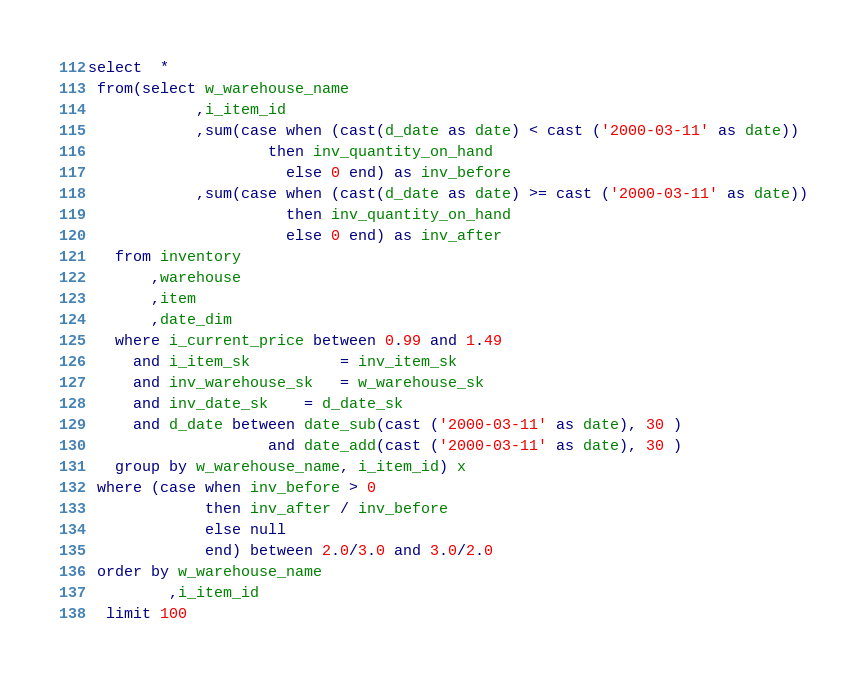<code> <loc_0><loc_0><loc_500><loc_500><_SQL_>select  *
 from(select w_warehouse_name
            ,i_item_id
            ,sum(case when (cast(d_date as date) < cast ('2000-03-11' as date))
	                then inv_quantity_on_hand 
                      else 0 end) as inv_before
            ,sum(case when (cast(d_date as date) >= cast ('2000-03-11' as date))
                      then inv_quantity_on_hand 
                      else 0 end) as inv_after
   from inventory
       ,warehouse
       ,item
       ,date_dim
   where i_current_price between 0.99 and 1.49
     and i_item_sk          = inv_item_sk
     and inv_warehouse_sk   = w_warehouse_sk
     and inv_date_sk    = d_date_sk
     and d_date between date_sub(cast ('2000-03-11' as date), 30 )
                    and date_add(cast ('2000-03-11' as date), 30 )
   group by w_warehouse_name, i_item_id) x
 where (case when inv_before > 0 
             then inv_after / inv_before 
             else null
             end) between 2.0/3.0 and 3.0/2.0
 order by w_warehouse_name
         ,i_item_id
  limit 100
</code> 